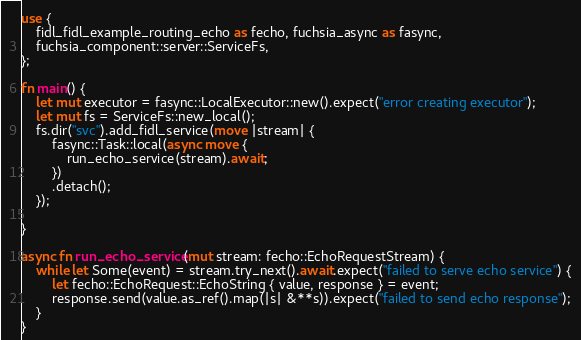Convert code to text. <code><loc_0><loc_0><loc_500><loc_500><_Rust_>use {
    fidl_fidl_example_routing_echo as fecho, fuchsia_async as fasync,
    fuchsia_component::server::ServiceFs,
};

fn main() {
    let mut executor = fasync::LocalExecutor::new().expect("error creating executor");
    let mut fs = ServiceFs::new_local();
    fs.dir("svc").add_fidl_service(move |stream| {
        fasync::Task::local(async move {
            run_echo_service(stream).await;
        })
        .detach();
    });

}

async fn run_echo_service(mut stream: fecho::EchoRequestStream) {
    while let Some(event) = stream.try_next().await.expect("failed to serve echo service") {
        let fecho::EchoRequest::EchoString { value, response } = event;
        response.send(value.as_ref().map(|s| &**s)).expect("failed to send echo response");
    }
}
</code> 